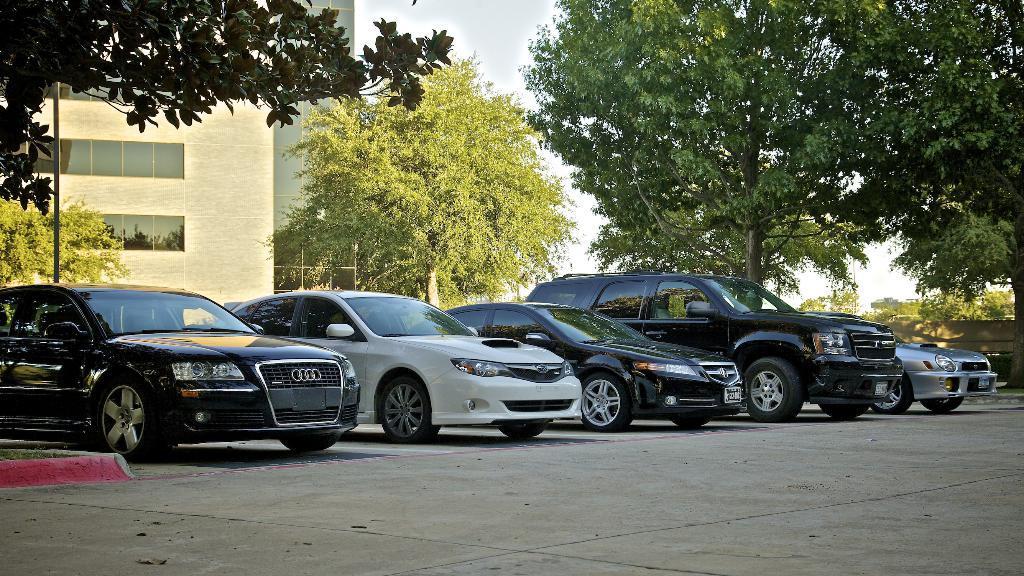Describe this image in one or two sentences. In this picture we can see vehicles on the road, pole, building, trees and in the background we can see the sky. 